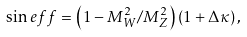Convert formula to latex. <formula><loc_0><loc_0><loc_500><loc_500>\sin e f f = \left ( 1 - M _ { W } ^ { 2 } / M _ { Z } ^ { 2 } \right ) \left ( 1 + \Delta \kappa \right ) ,</formula> 